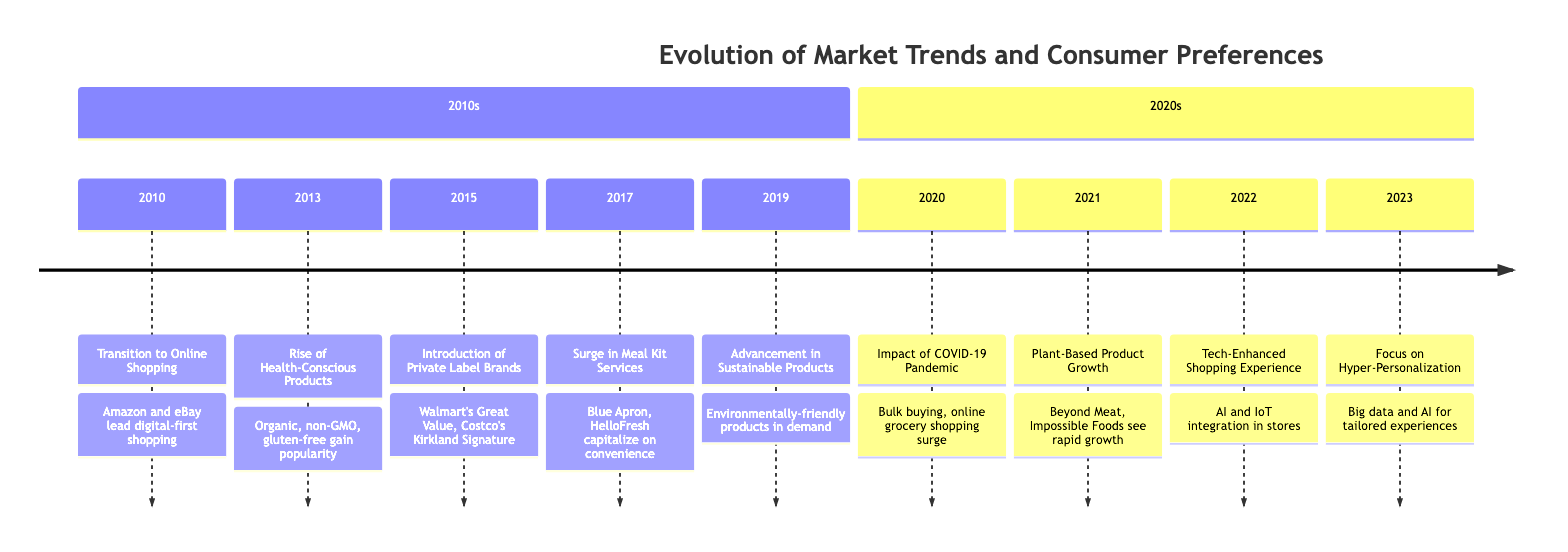What event marked the transition to online shopping? The diagram indicates that the event for the transition to online shopping occurred in 2010, led by Amazon and eBay shifting consumer buying habits online.
Answer: Transition to Online Shopping Which year experienced a surge in meal kit services? According to the diagram, the surge in meal kit services occurred in 2017, with companies like Blue Apron and HelloFresh capitalizing on convenience trends.
Answer: 2017 What product trend rose significantly in 2021? The diagram shows that in 2021, there was significant growth in plant-based products, with brands like Beyond Meat and Impossible Foods becoming popular.
Answer: Plant-Based Product Growth How did the COVID-19 pandemic impact consumer buying behavior? The visual information states that in 2020, the COVID-19 pandemic led to a sharp increase in demand for home essentials and bulk buying, with online grocery shopping becoming critical.
Answer: Impact of COVID-19 Pandemic What key trend was introduced by supermarkets in 2015? The diagram identifies the introduction of private label brands as a key trend brought by supermarkets in 2015, with examples including Walmart's Great Value and Costco's Kirkland Signature.
Answer: Introduction of Private Label Brands Which event in 2019 reflects an advancement in environmental consciousness? The event that occurred in 2019, according to the diagram, reflects advancements in sustainable products, driven by consumer demand for environmentally-friendly items.
Answer: Advancement in Sustainable Products What technology integration was highlighted in 2022? In 2022, the integration of AI and IoT for a tech-enhanced shopping experience was highlighted in the diagram, particularly with Amazon Go stores enabling seamless purchasing.
Answer: Tech-Enhanced Shopping Experience In which year did hyper-personalization become a focus for retailers? The timeline shows that the focus on hyper-personalization began in 2023, where retailers used big data and AI for personalized shopping experiences.
Answer: 2023 How many events are listed for the year 2010? Reviewing the diagram, only one event is listed for the year 2010, which is the transition to online shopping led by Amazon and eBay.
Answer: 1 